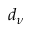<formula> <loc_0><loc_0><loc_500><loc_500>d _ { \nu }</formula> 